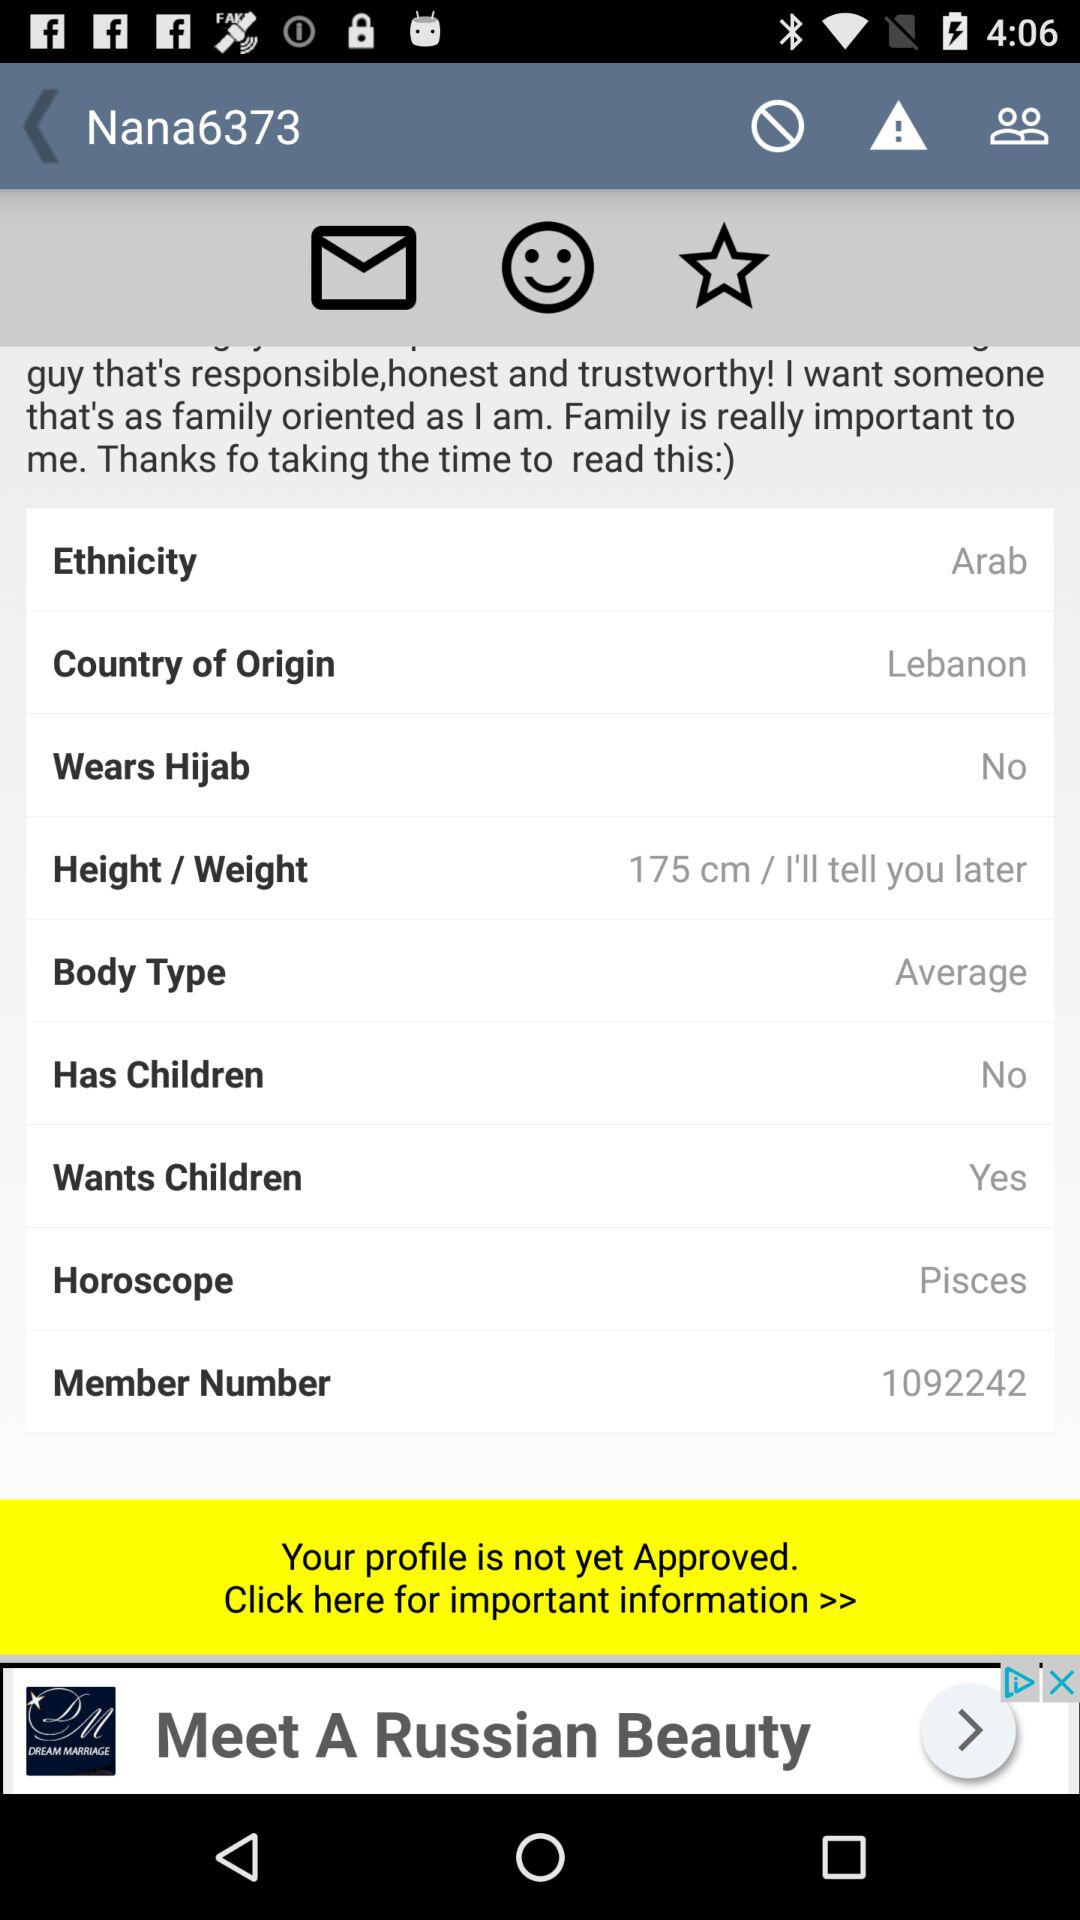What is the given body type? The given body type is "Average". 